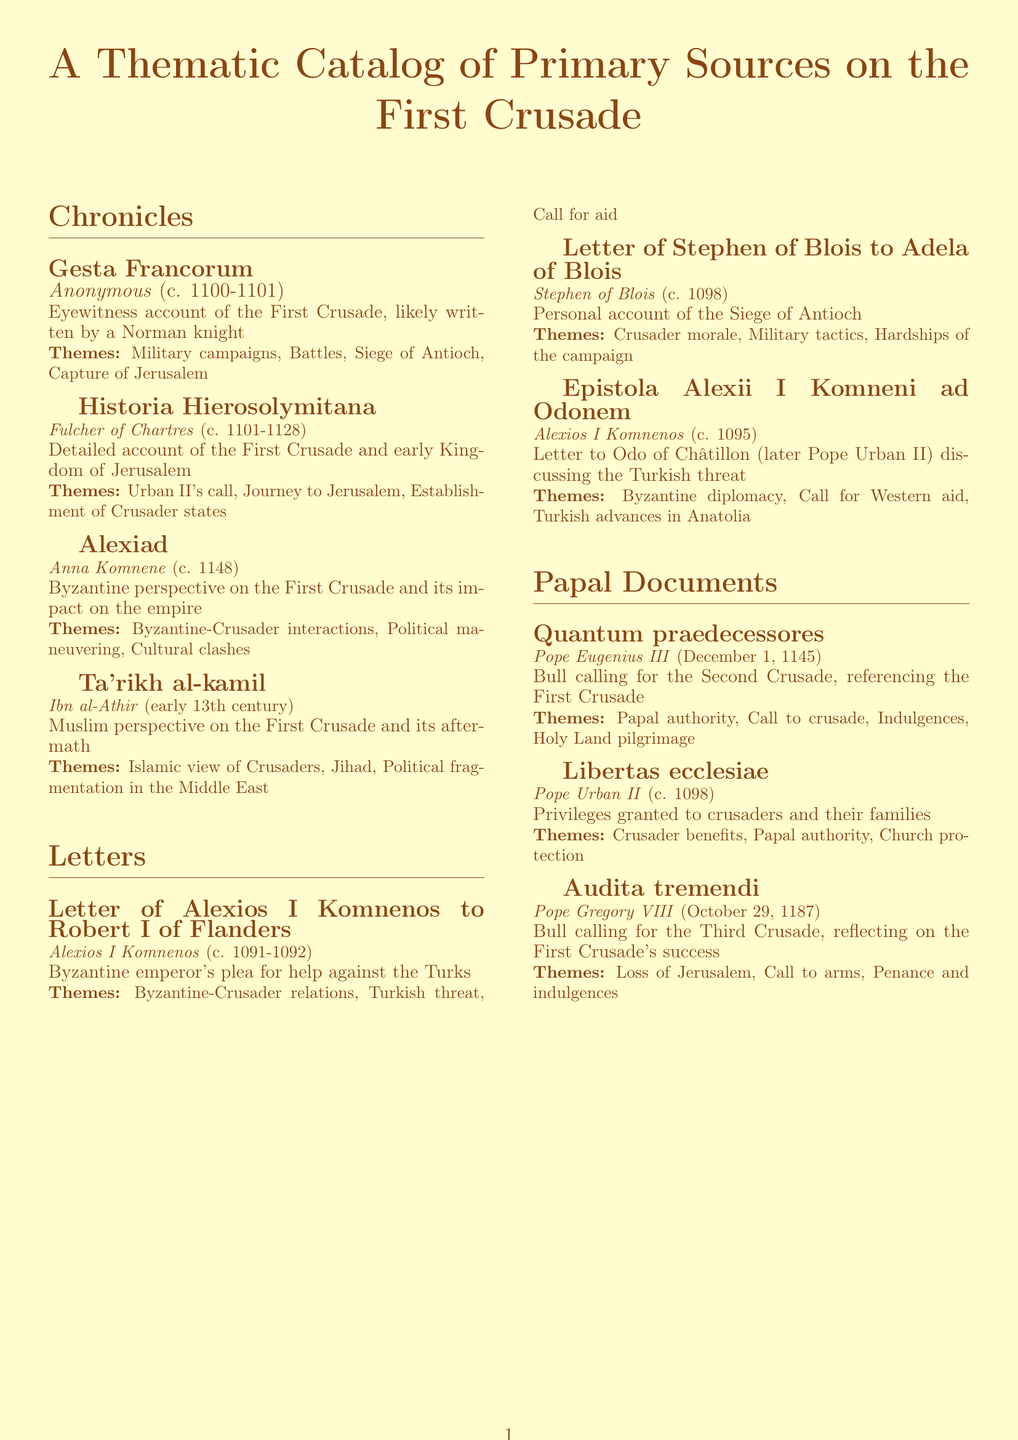What is the title of the eyewitness account of the First Crusade? The document lists "Gesta Francorum" as the eyewitness account written by an anonymous author.
Answer: Gesta Francorum Who authored the letter pleading for help against the Turks? The letter was authored by Alexios I Komnenos, the Byzantine emperor.
Answer: Alexios I Komnenos What is the date of the papal document calling for the Second Crusade? The document states that "Quantum praedecessores" was issued on December 1, 1145.
Answer: December 1, 1145 Which source provides a personal account of the Siege of Antioch? The document highlights "Letter of Stephen of Blois to Adela of Blois" as providing a personal account of the Siege of Antioch.
Answer: Letter of Stephen of Blois to Adela of Blois What language is the "Alexiad" written in? According to the document, "Alexiad" is written in Greek.
Answer: Greek What theme is associated with the letter from Stephen of Blois? The document states that "Crusader morale" is one of the themes associated with Stephen of Blois's letter.
Answer: Crusader morale How many chronicles are listed in the document? The document lists a total of four chronicles under the "Chronicles" section.
Answer: Four What perspective does "Ta'rikh al-kamil" provide? The document indicates that "Ta'rikh al-kamil" offers a Muslim perspective on the First Crusade and its aftermath.
Answer: Muslim perspective Which document reflects on the First Crusade's success when calling for the Third Crusade? The document identifies "Audita tremendi" as the papal bull that reflects on the First Crusade's success.
Answer: Audita tremendi 